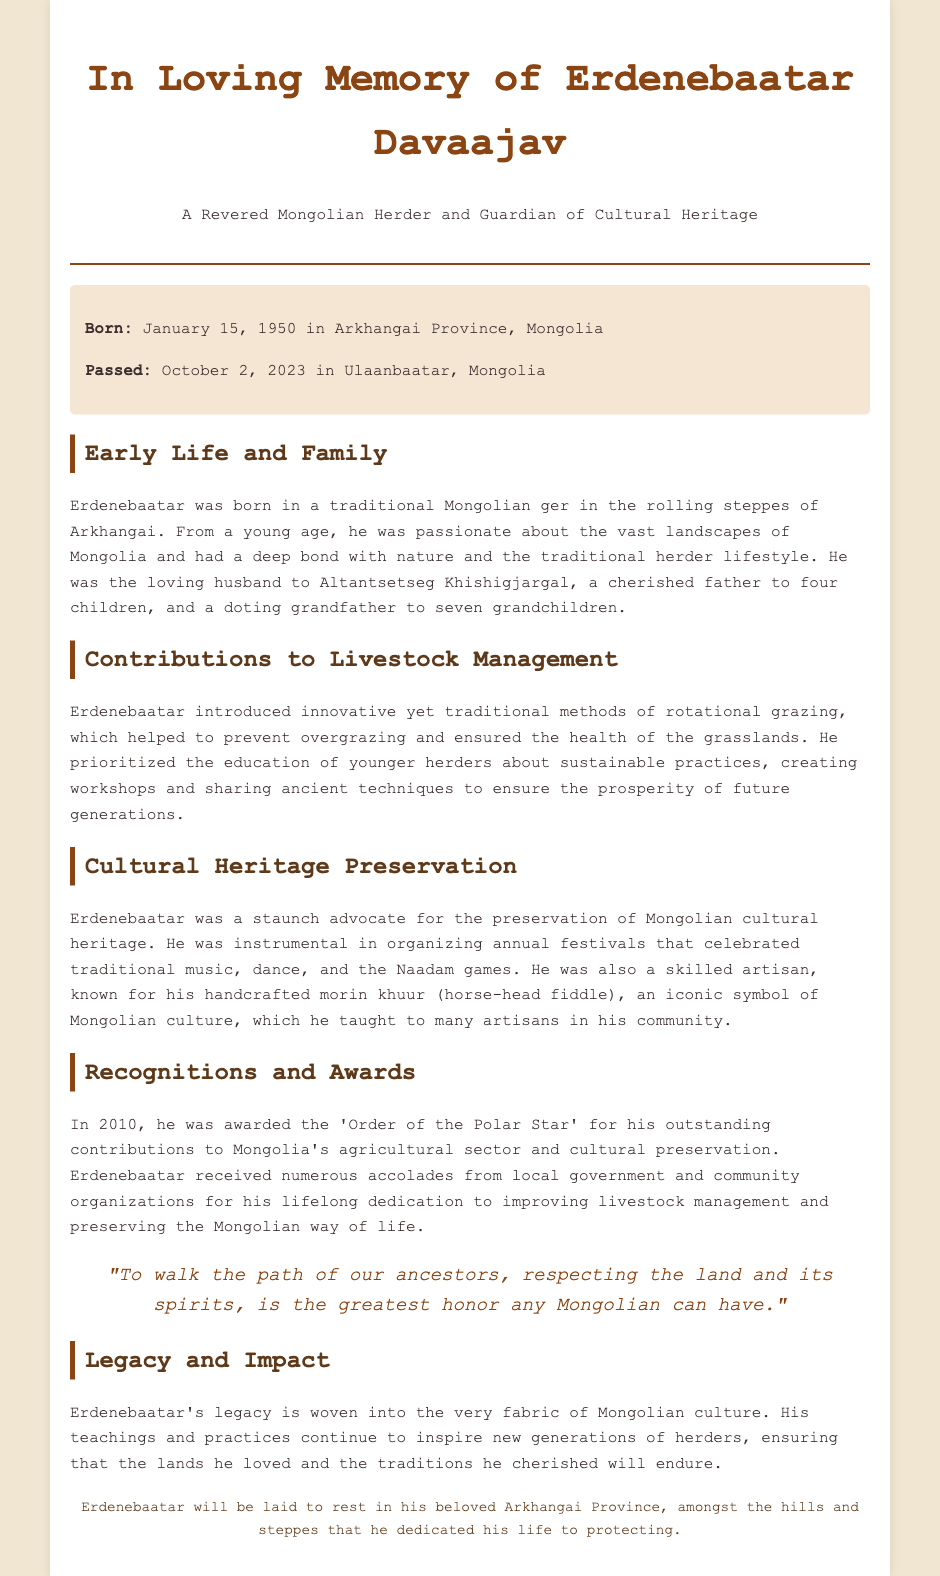What was Erdenebaatar's birth date? The document clearly states that Erdenebaatar was born on January 15, 1950.
Answer: January 15, 1950 Where did Erdenebaatar pass away? The document indicates that Erdenebaatar passed away in Ulaanbaatar, Mongolia.
Answer: Ulaanbaatar, Mongolia How many grandchildren did Erdenebaatar have? The document mentions that he was a doting grandfather to seven grandchildren.
Answer: Seven What award did Erdenebaatar receive in 2010? According to the document, he was awarded the 'Order of the Polar Star' for his contributions.
Answer: Order of the Polar Star What traditional instrument did Erdenebaatar craft? The document specifies that he was known for his handcrafted morin khuur.
Answer: Morin khuur What is one method Erdenebaatar introduced for livestock management? The document notes that he introduced rotational grazing to prevent overgrazing.
Answer: Rotational grazing What did Erdenebaatar advocate for besides livestock management? The document states he was a staunch advocate for preserving Mongolian cultural heritage.
Answer: Cultural heritage What was one of Erdenebaatar's contributions to education? The document mentions that he prioritized educating younger herders about sustainable practices.
Answer: Educating younger herders Where will Erdenebaatar be laid to rest? The document says he will be laid to rest in Arkhangai Province.
Answer: Arkhangai Province 